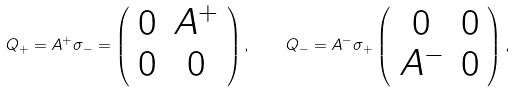Convert formula to latex. <formula><loc_0><loc_0><loc_500><loc_500>Q _ { + } = A ^ { + } \sigma _ { - } = \left ( \begin{array} { c c } 0 & { A ^ { + } } \\ 0 & 0 \end{array} \right ) , \quad Q _ { - } = A ^ { - } \sigma _ { + } \left ( \begin{array} { c c } 0 & 0 \\ { A ^ { - } } & 0 \end{array} \right ) ,</formula> 